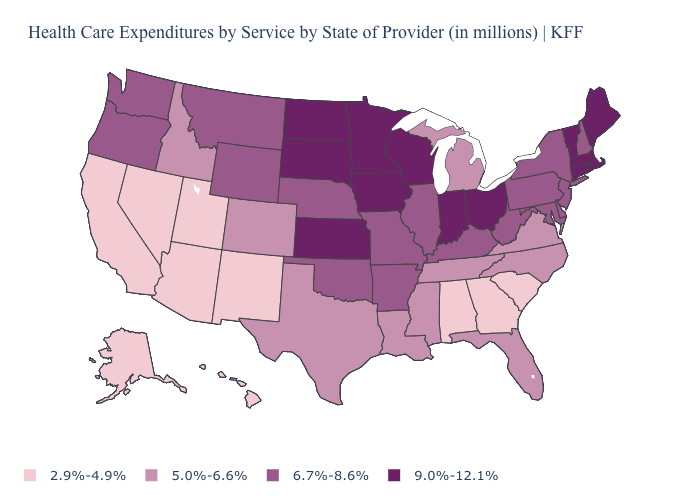Does Nevada have a lower value than Hawaii?
Short answer required. No. What is the value of Maryland?
Answer briefly. 6.7%-8.6%. Which states have the lowest value in the USA?
Quick response, please. Alabama, Alaska, Arizona, California, Georgia, Hawaii, Nevada, New Mexico, South Carolina, Utah. How many symbols are there in the legend?
Keep it brief. 4. Is the legend a continuous bar?
Short answer required. No. Name the states that have a value in the range 6.7%-8.6%?
Keep it brief. Arkansas, Delaware, Illinois, Kentucky, Maryland, Missouri, Montana, Nebraska, New Hampshire, New Jersey, New York, Oklahoma, Oregon, Pennsylvania, Washington, West Virginia, Wyoming. Does Vermont have a lower value than New Jersey?
Write a very short answer. No. Which states have the lowest value in the USA?
Concise answer only. Alabama, Alaska, Arizona, California, Georgia, Hawaii, Nevada, New Mexico, South Carolina, Utah. What is the value of Maryland?
Give a very brief answer. 6.7%-8.6%. Does the first symbol in the legend represent the smallest category?
Give a very brief answer. Yes. What is the value of New Jersey?
Write a very short answer. 6.7%-8.6%. Does the map have missing data?
Keep it brief. No. Does Arkansas have the highest value in the South?
Short answer required. Yes. What is the value of Nevada?
Write a very short answer. 2.9%-4.9%. 